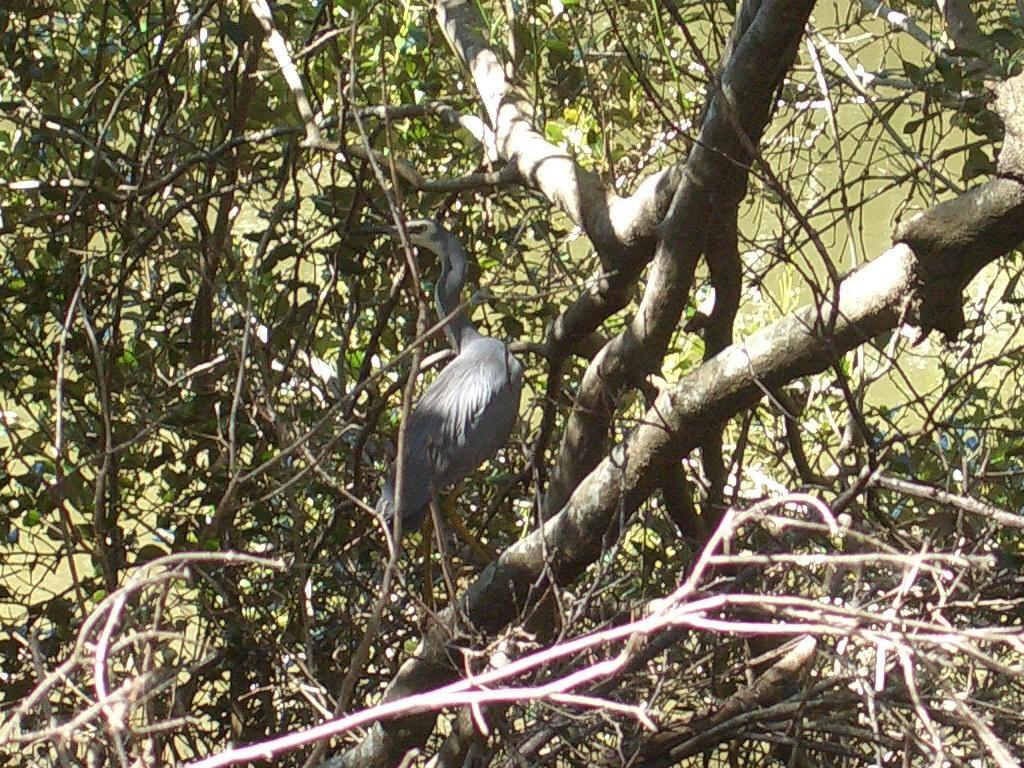What type of animal can be seen in the image? There is a bird in the image. What is the natural environment depicted in the image? There are trees in the image. What can be seen in the background of the image? There is water visible in the background of the image. What type of holiday is being celebrated in the image? There is no indication of a holiday being celebrated in the image. What sound does the bird make in the image? The image is static, so no sound can be heard. 